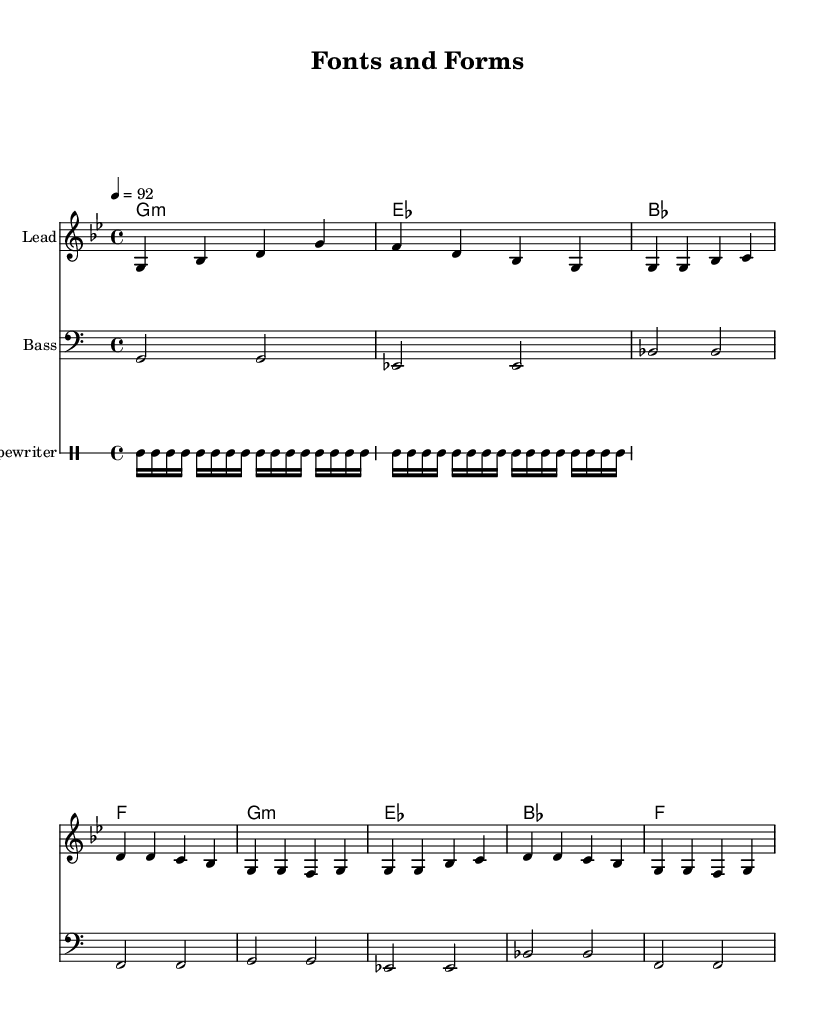what is the key signature of this music? The key signature is G minor. This is determined by looking at the key signature indicator, which is present at the beginning of the staff. G minor has two flats, B♭ and E♭, indicating it is in a minor key.
Answer: G minor what is the time signature of this music? The time signature is 4/4. This can be found at the beginning of the sheet music, indicating that there are four beats in each measure and that the quarter note gets one beat.
Answer: 4/4 what is the tempo marking for this piece? The tempo marking is 92. This is indicated by the number following the tempo symbol (which is not explicitly shown in text), signifying the beats per minute (BPM) that the piece should be played at.
Answer: 92 how many measures are in the score? The score consists of 8 measures. This can be counted visually across the staff, where each measure is separated by bar lines, and each grouping spans the full width of the four beats allowed in a 4/4 time signature.
Answer: 8 which instrument is indicated as the 'Typewriter'? The 'Typewriter' is a percussion instrument in this score, as indicated by the DrumStaff heading that explicitly states that this is a typewriter rhythm part. It is unique in that it uses a non-conventional sound to fit the hip-hop genre.
Answer: Typewriter what is the prominent note of the chorus? The prominent note in the chorus is G. During the repeated sections of the chorus, the first note played is consistently a G, making it the focal point of this melody.
Answer: G how does the rhythm pattern contribute to the rap style? The rhythm pattern features a repeated typewriter sound underlies the lead melody which aligns with typical hip-hop tracks that emphasize a strong and steady rhythmic foundation, giving it a percussive quality. The use of drums and distinct accents also supports this style.
Answer: Strong rhythmic foundation 